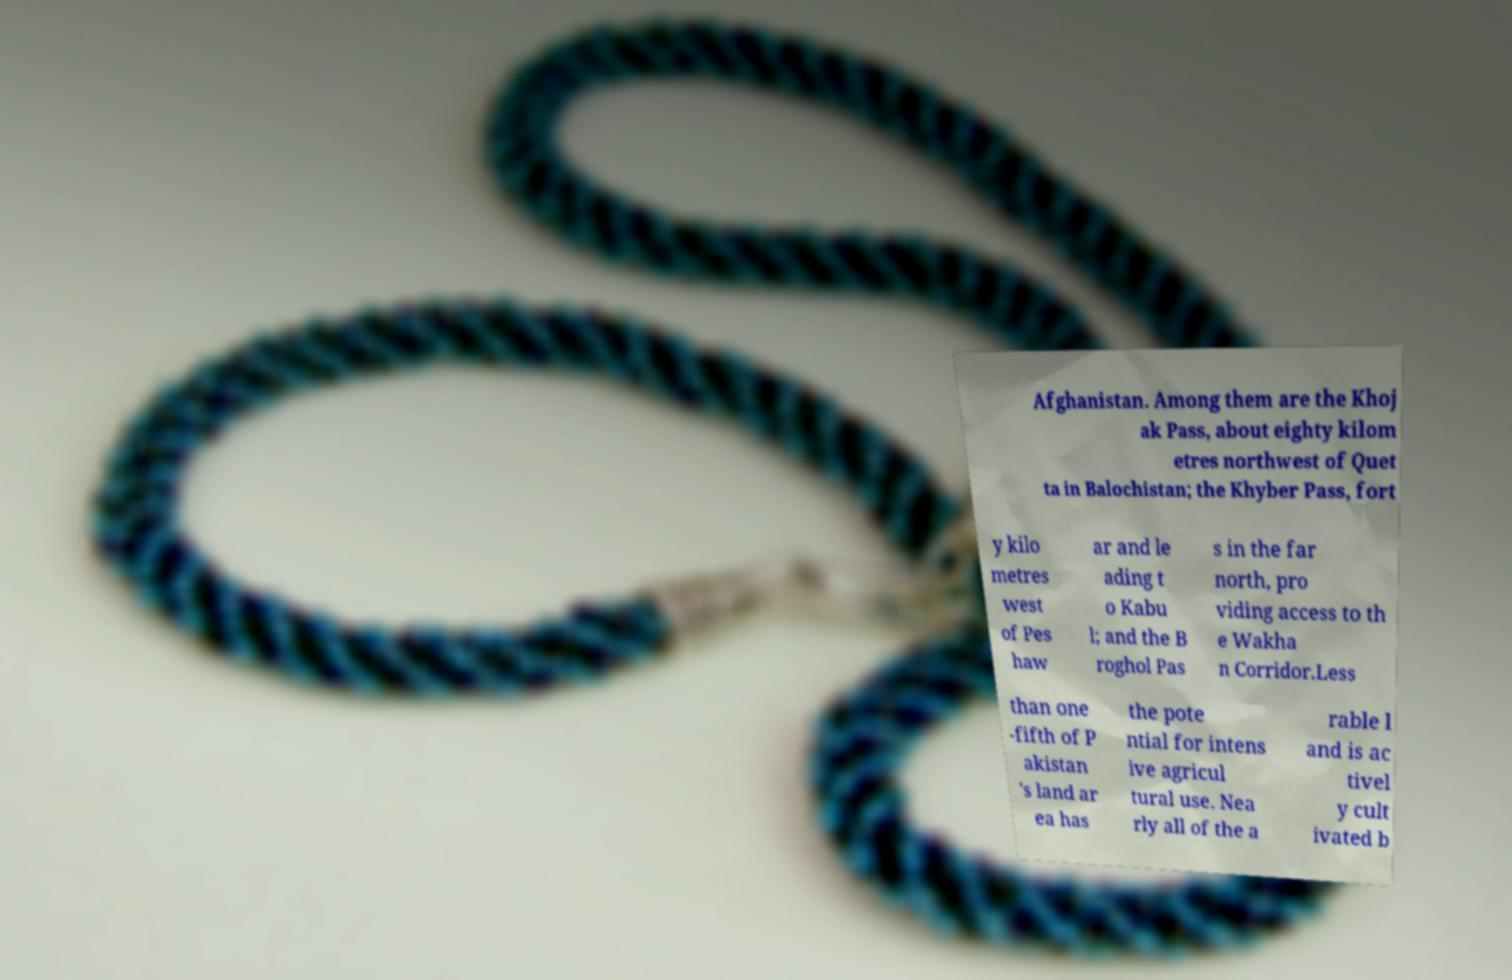Please read and relay the text visible in this image. What does it say? Afghanistan. Among them are the Khoj ak Pass, about eighty kilom etres northwest of Quet ta in Balochistan; the Khyber Pass, fort y kilo metres west of Pes haw ar and le ading t o Kabu l; and the B roghol Pas s in the far north, pro viding access to th e Wakha n Corridor.Less than one -fifth of P akistan 's land ar ea has the pote ntial for intens ive agricul tural use. Nea rly all of the a rable l and is ac tivel y cult ivated b 